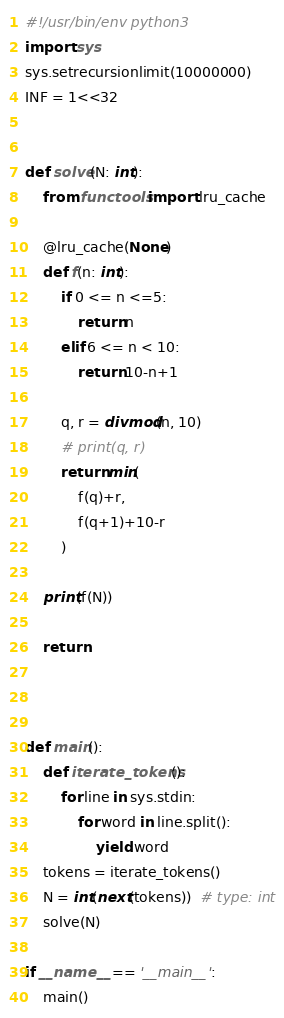Convert code to text. <code><loc_0><loc_0><loc_500><loc_500><_Python_>#!/usr/bin/env python3
import sys
sys.setrecursionlimit(10000000)
INF = 1<<32


def solve(N: int):
    from functools import lru_cache

    @lru_cache(None)
    def f(n: int):
        if 0 <= n <=5:
            return n
        elif 6 <= n < 10:
            return 10-n+1

        q, r = divmod(n, 10)
        # print(q, r)
        return min(
            f(q)+r,
            f(q+1)+10-r
        )

    print(f(N))

    return



def main():
    def iterate_tokens():
        for line in sys.stdin:
            for word in line.split():
                yield word
    tokens = iterate_tokens()
    N = int(next(tokens))  # type: int
    solve(N)

if __name__ == '__main__':
    main()
</code> 